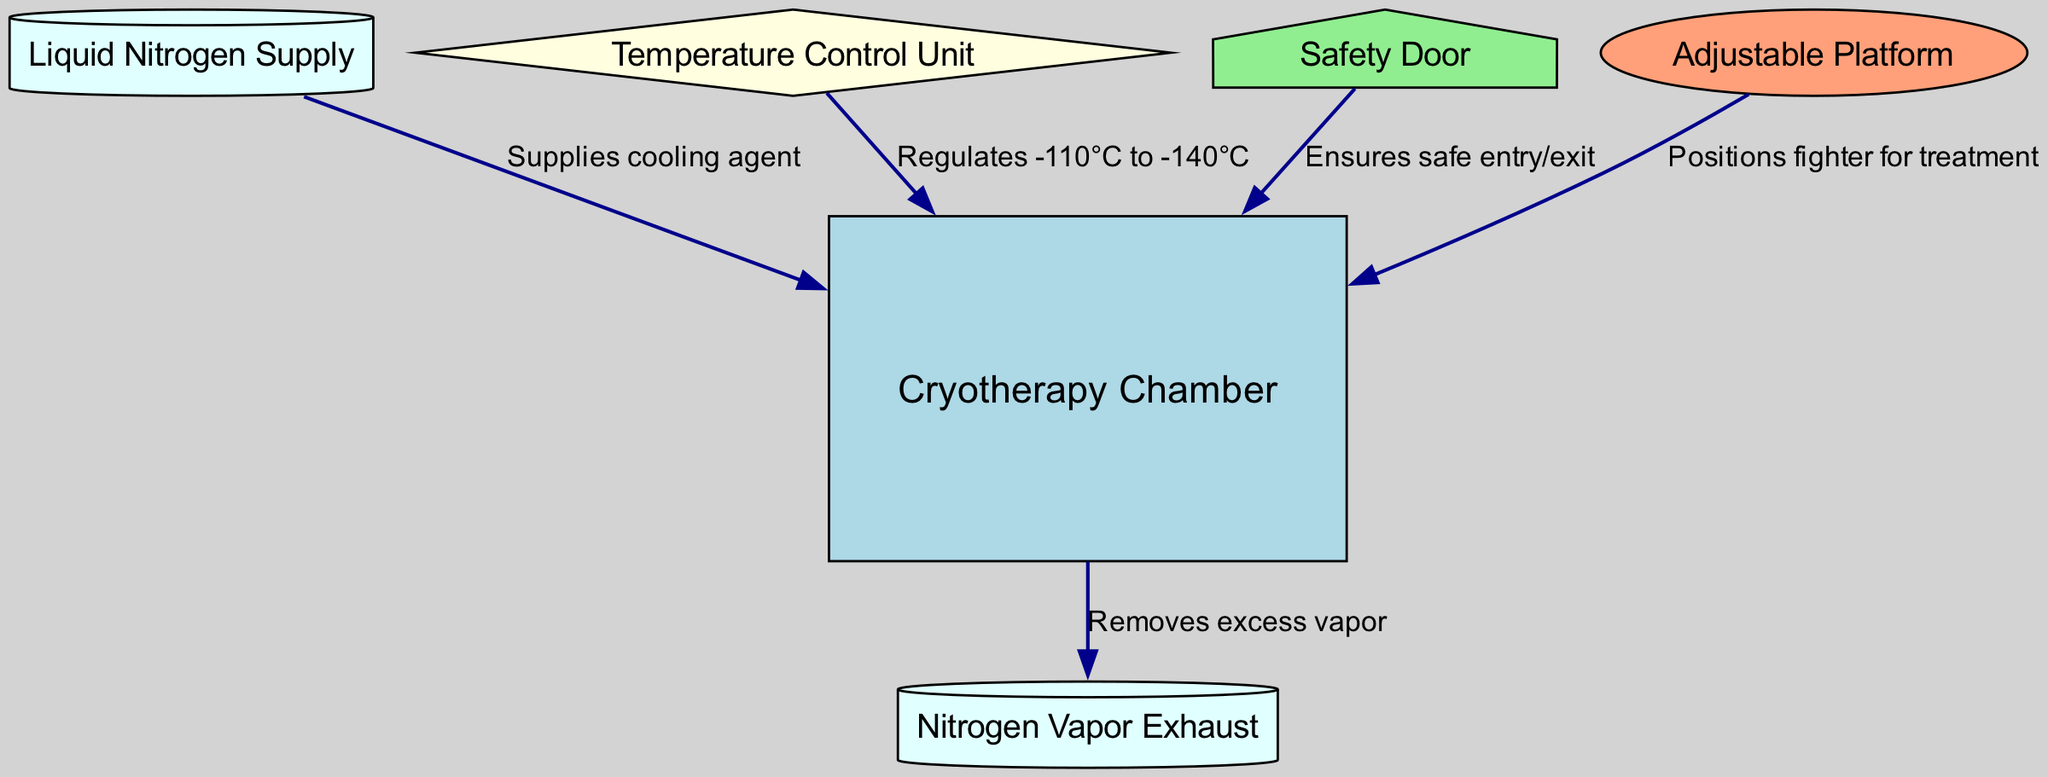What is the main cooling agent in the cryotherapy chamber? The diagram shows that the cooling agent supplied to the chamber is "Liquid Nitrogen". Therefore, the answer is found by identifying the node that corresponds to the supply of cooling agent.
Answer: Liquid Nitrogen How many nodes are present in the diagram? The diagram lists six nodes: Cryotherapy Chamber, Liquid Nitrogen Supply, Temperature Control Unit, Safety Door, Nitrogen Vapor Exhaust, and Adjustable Platform. Counting these gives the total number of nodes.
Answer: 6 What temperature range does the temperature control unit regulate? According to the diagram, the Temperature Control Unit regulates temperatures from -110°C to -140°C. This is shown in the labeled edge connecting it to the chamber.
Answer: -110°C to -140°C What is the purpose of the safety door? The Safety Door ensures safe entry and exit into the cryotherapy chamber. The diagram specifies this function through its labeled edge connected to the chamber.
Answer: Ensures safe entry/exit Which component is responsible for removing excess vapor? From the diagram, the edge labeled “Removes excess vapor” connects the Cryotherapy Chamber to the Nitrogen Vapor Exhaust. This indicates that the exhaust system takes care of vapor removal.
Answer: Nitrogen Vapor Exhaust What does the adjustable platform do? In the diagram, the Adjustable Platform is responsible for positioning the fighter for treatment as indicated by the edge labeled accordingly. Thus, it plays a critical role in the setup for cryotherapy.
Answer: Positions fighter for treatment Which unit controls the temperature in the chamber? The diagram clearly labels the Temperature Control Unit as the component that regulates the temperature in the Cryotherapy Chamber. Therefore, this node is directly responsible for temperature control.
Answer: Temperature Control Unit What is the connection between the liquid nitrogen supply and the chamber? The edge labeled "Supplies cooling agent" indicates that the Liquid Nitrogen Supply is directly connected to the Cryotherapy Chamber, contributing to its cooling function.
Answer: Supplies cooling agent How many edges connect the nodes in this diagram? The diagram has five edges connecting the nodes. Each edge represents a specific relationship between the components within the cryotherapy chamber setup.
Answer: 5 